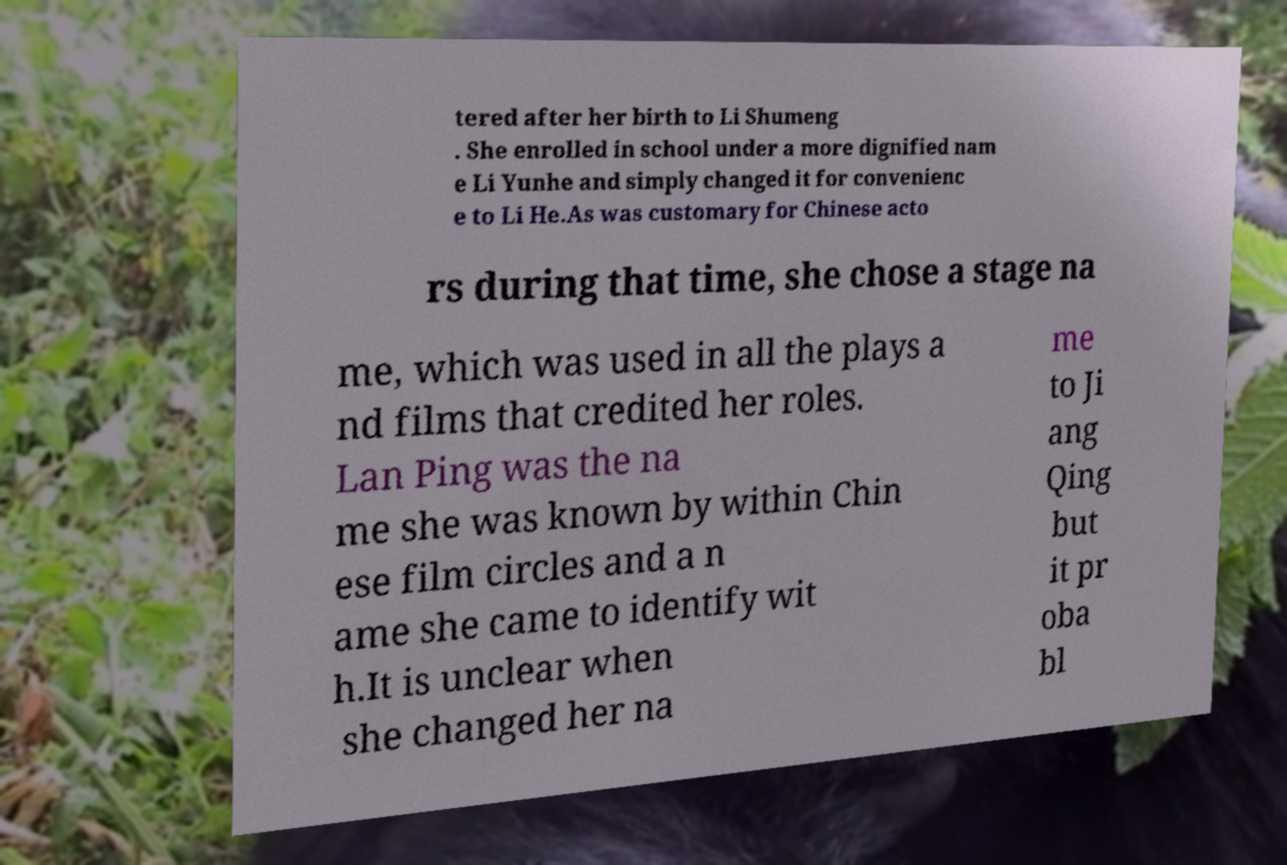Please identify and transcribe the text found in this image. tered after her birth to Li Shumeng . She enrolled in school under a more dignified nam e Li Yunhe and simply changed it for convenienc e to Li He.As was customary for Chinese acto rs during that time, she chose a stage na me, which was used in all the plays a nd films that credited her roles. Lan Ping was the na me she was known by within Chin ese film circles and a n ame she came to identify wit h.It is unclear when she changed her na me to Ji ang Qing but it pr oba bl 